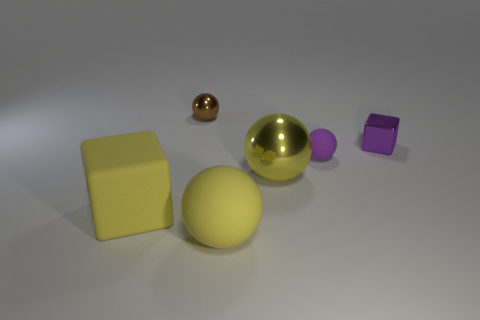Add 1 small yellow matte objects. How many objects exist? 7 Subtract all spheres. How many objects are left? 2 Subtract 0 cyan cylinders. How many objects are left? 6 Subtract all small blocks. Subtract all large yellow shiny objects. How many objects are left? 4 Add 6 yellow shiny balls. How many yellow shiny balls are left? 7 Add 3 big matte cubes. How many big matte cubes exist? 4 